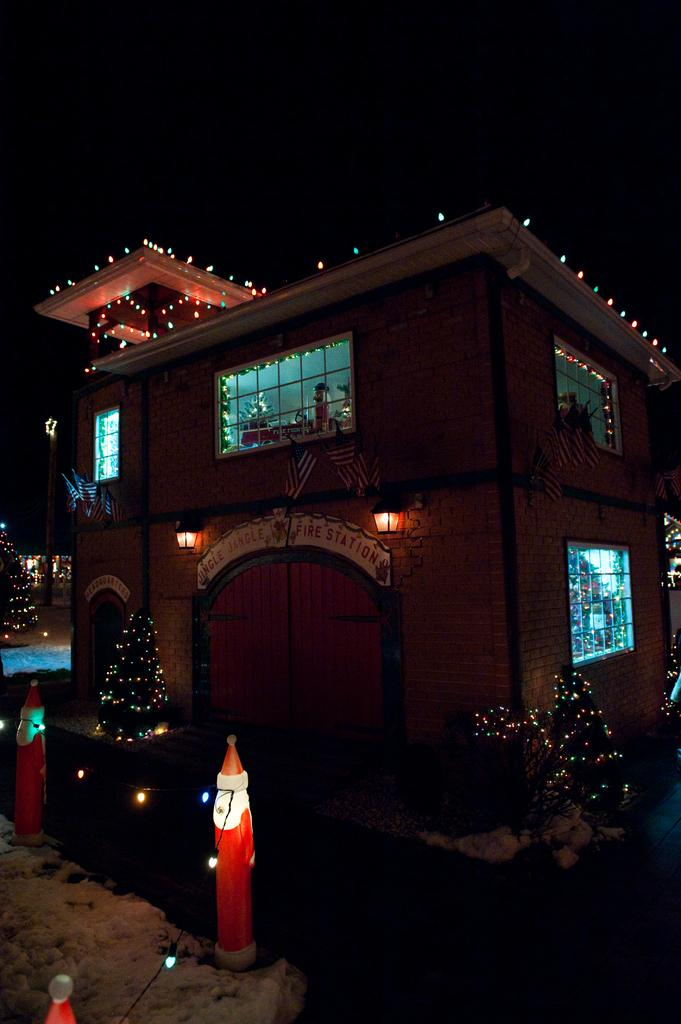What structures can be seen in the image? There are poles and a house in the image. What is near the house in the image? There are Xmas trees decorated with lights near the house in the image. What type of windows does the house have? The house has glass windows. What is present on the left side of the image? There is snow on the left side of the image. What is the color of the sky in the background? The sky in the background is dark. How many apples are hanging from the poles in the image? There are no apples present in the image; the poles are not related to apples. Is there a volleyball game happening in the image? There is no volleyball game present in the image. What type of jewel can be seen on the Xmas trees in the image? There are no jewels present on the Xmas trees in the image; they are decorated with lights. 